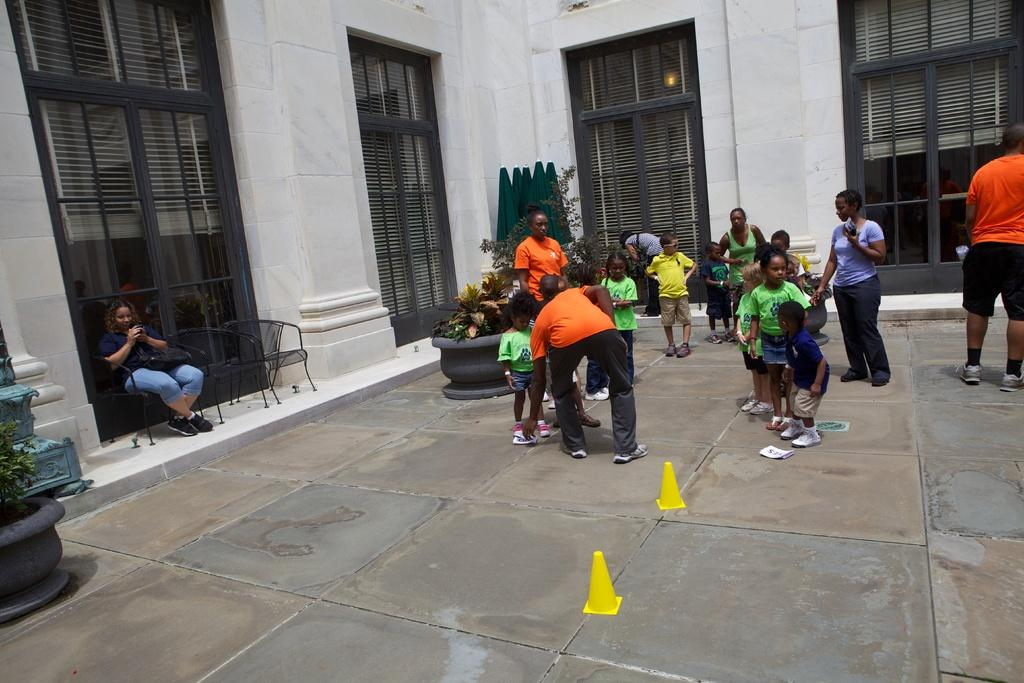What is the main feature of the image? There is a surface in the image. What can be seen on the surface? There are children on the surface. What is visible in the background of the image? There is a wall with doors in the background. Can you describe the man's position in the image? There is a man sitting on a chair near the wall. What type of kite is the man holding in the image? There is no kite present in the image; the man is sitting on a chair near the wall. Is the camera visible in the image? There is no camera mentioned or visible in the image. 